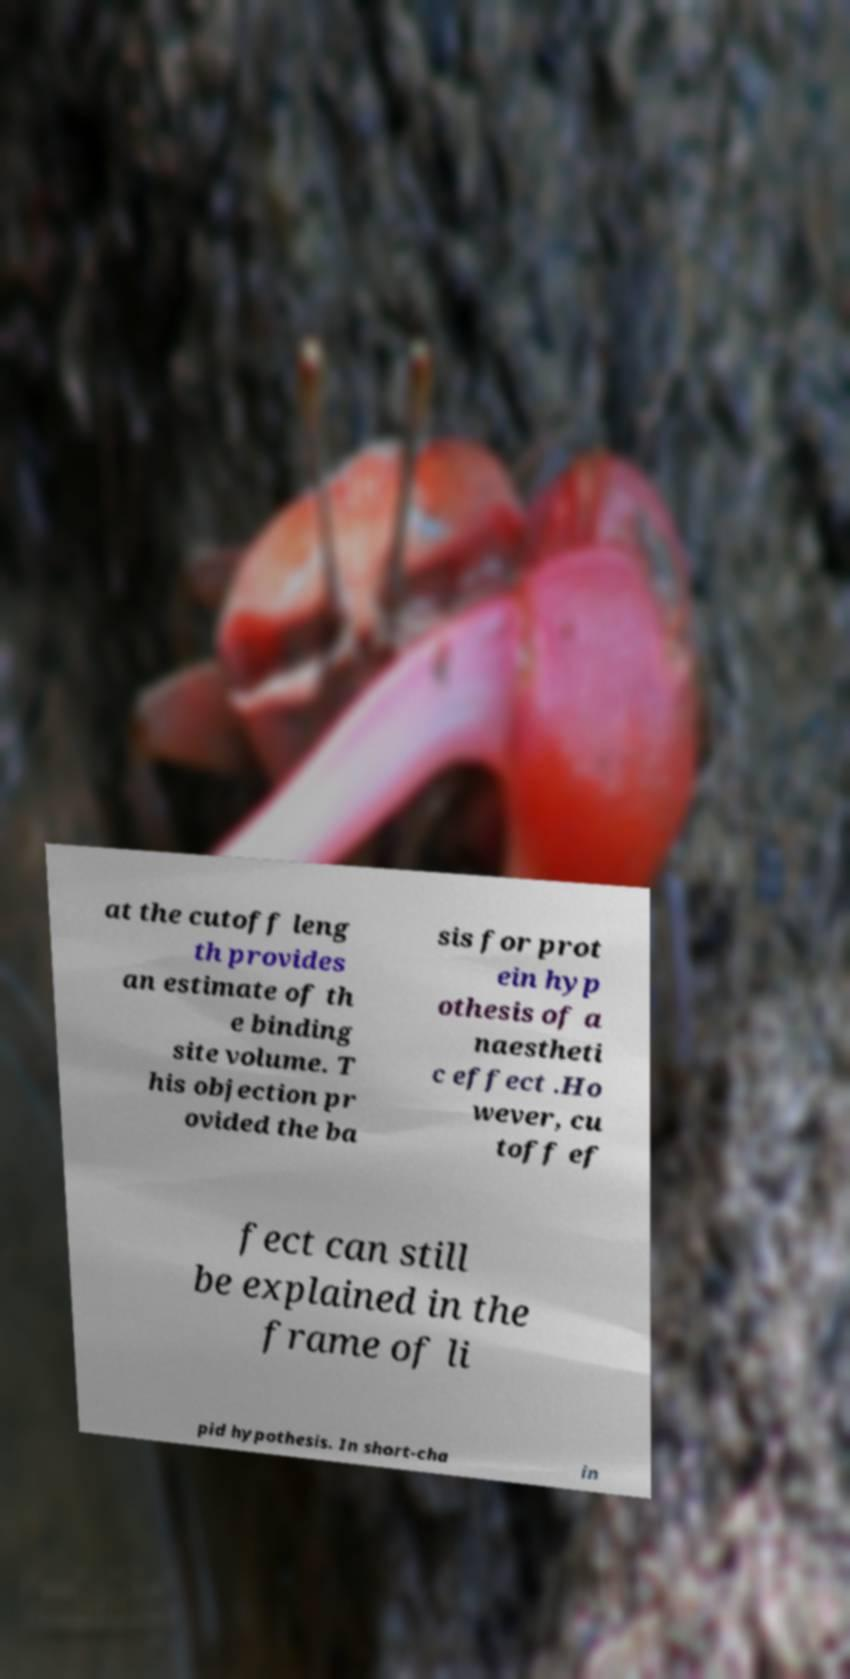Could you extract and type out the text from this image? at the cutoff leng th provides an estimate of th e binding site volume. T his objection pr ovided the ba sis for prot ein hyp othesis of a naestheti c effect .Ho wever, cu toff ef fect can still be explained in the frame of li pid hypothesis. In short-cha in 